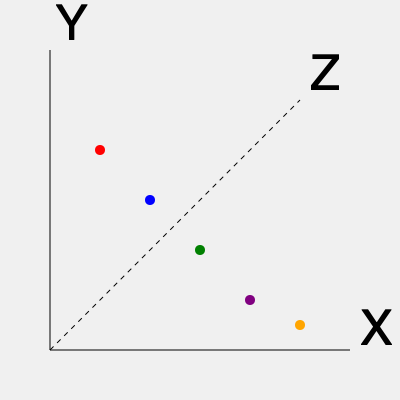In the given 3D scatter plot, which arrangement of data points could be considered the most creative and innovative, challenging the conventional focus on efficiency? To answer this question, we need to consider the following steps:

1. Examine the distribution of points:
   The points are arranged in a descending pattern from left to right along the X and Y axes.

2. Consider the efficiency perspective:
   An efficient arrangement would typically follow a clear, predictable pattern, such as a straight line or a simple curve.

3. Evaluate creativity and innovation:
   Creative and innovative arrangements often break from conventional patterns, introducing unexpected elements or relationships between data points.

4. Analyze the given arrangement:
   The points form a diagonal line when viewed from above (X-Y plane), but they also descend along the Z-axis, creating a 3D spiral-like pattern.

5. Consider alternative arrangements:
   A truly creative arrangement might involve:
   - Clustering points in unexpected ways
   - Creating abstract shapes or patterns
   - Utilizing the full 3D space rather than adhering to a planar arrangement

6. Evaluate the given arrangement against creative criteria:
   While the current arrangement shows some creativity by utilizing the Z-axis, it still follows a relatively predictable pattern.

7. Propose a more creative arrangement:
   A more innovative approach could involve arranging the points to form a 3D shape like a cube, sphere, or abstract sculpture, utilizing color to represent additional dimensions of data.

8. Conclude:
   The most creative arrangement would break from the current linear pattern and utilize the 3D space more fully, perhaps forming a recognizable 3D shape or an abstract pattern that reveals unexpected relationships in the data.
Answer: A 3D sculptural arrangement forming an abstract or recognizable shape 